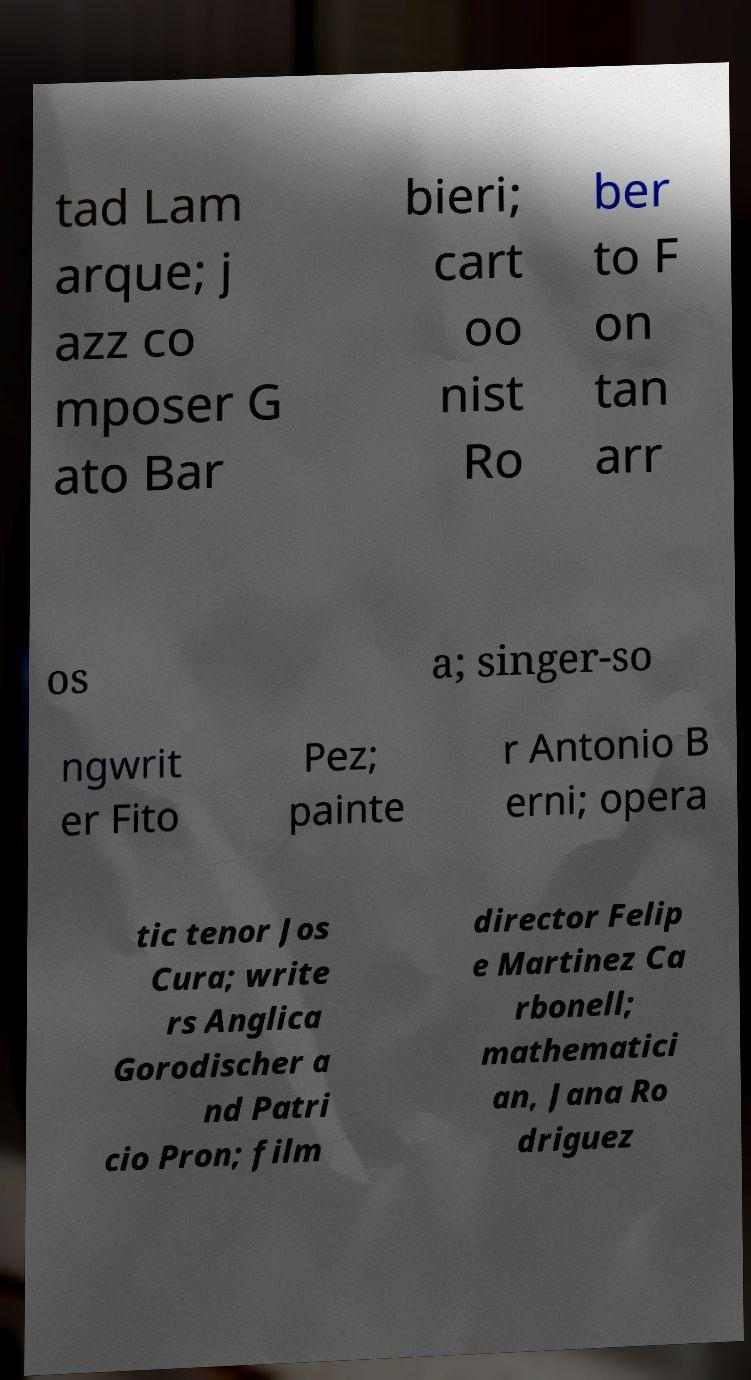I need the written content from this picture converted into text. Can you do that? tad Lam arque; j azz co mposer G ato Bar bieri; cart oo nist Ro ber to F on tan arr os a; singer-so ngwrit er Fito Pez; painte r Antonio B erni; opera tic tenor Jos Cura; write rs Anglica Gorodischer a nd Patri cio Pron; film director Felip e Martinez Ca rbonell; mathematici an, Jana Ro driguez 